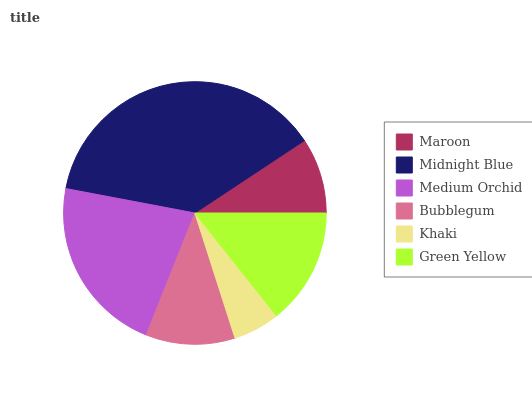Is Khaki the minimum?
Answer yes or no. Yes. Is Midnight Blue the maximum?
Answer yes or no. Yes. Is Medium Orchid the minimum?
Answer yes or no. No. Is Medium Orchid the maximum?
Answer yes or no. No. Is Midnight Blue greater than Medium Orchid?
Answer yes or no. Yes. Is Medium Orchid less than Midnight Blue?
Answer yes or no. Yes. Is Medium Orchid greater than Midnight Blue?
Answer yes or no. No. Is Midnight Blue less than Medium Orchid?
Answer yes or no. No. Is Green Yellow the high median?
Answer yes or no. Yes. Is Bubblegum the low median?
Answer yes or no. Yes. Is Maroon the high median?
Answer yes or no. No. Is Medium Orchid the low median?
Answer yes or no. No. 